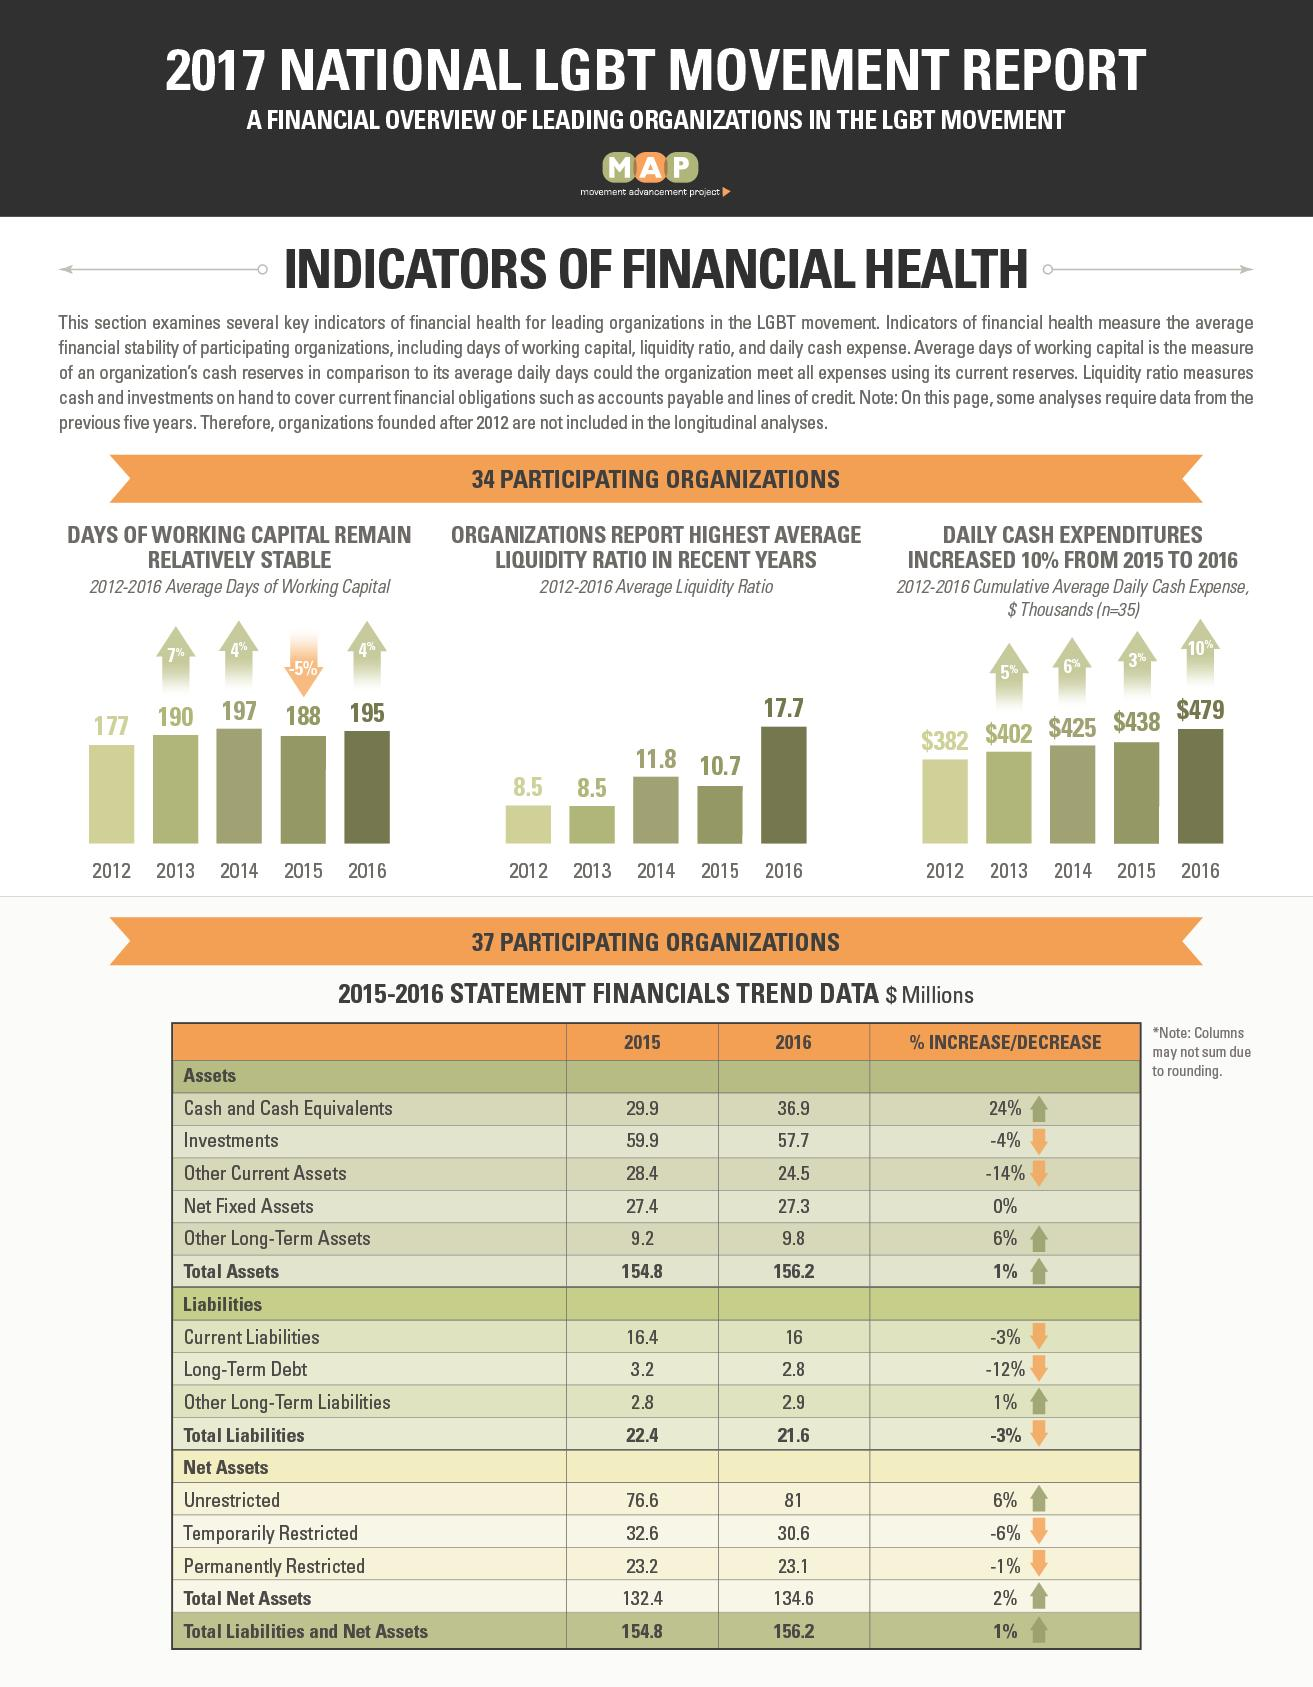Specify some key components in this picture. The total net fixed assets for the years 2015 and 2016 amounted to $54.7 million. The total liabilities and net assets in 2015 and 2016 were $311 million. The total assets increased by $1.4 million from 2015 to 2016. As of 2015, the total temporarily restricted and permanently restricted net assets amounted to $55.8 million. In 2015 and 2016, the total investments were $117.6 million. 